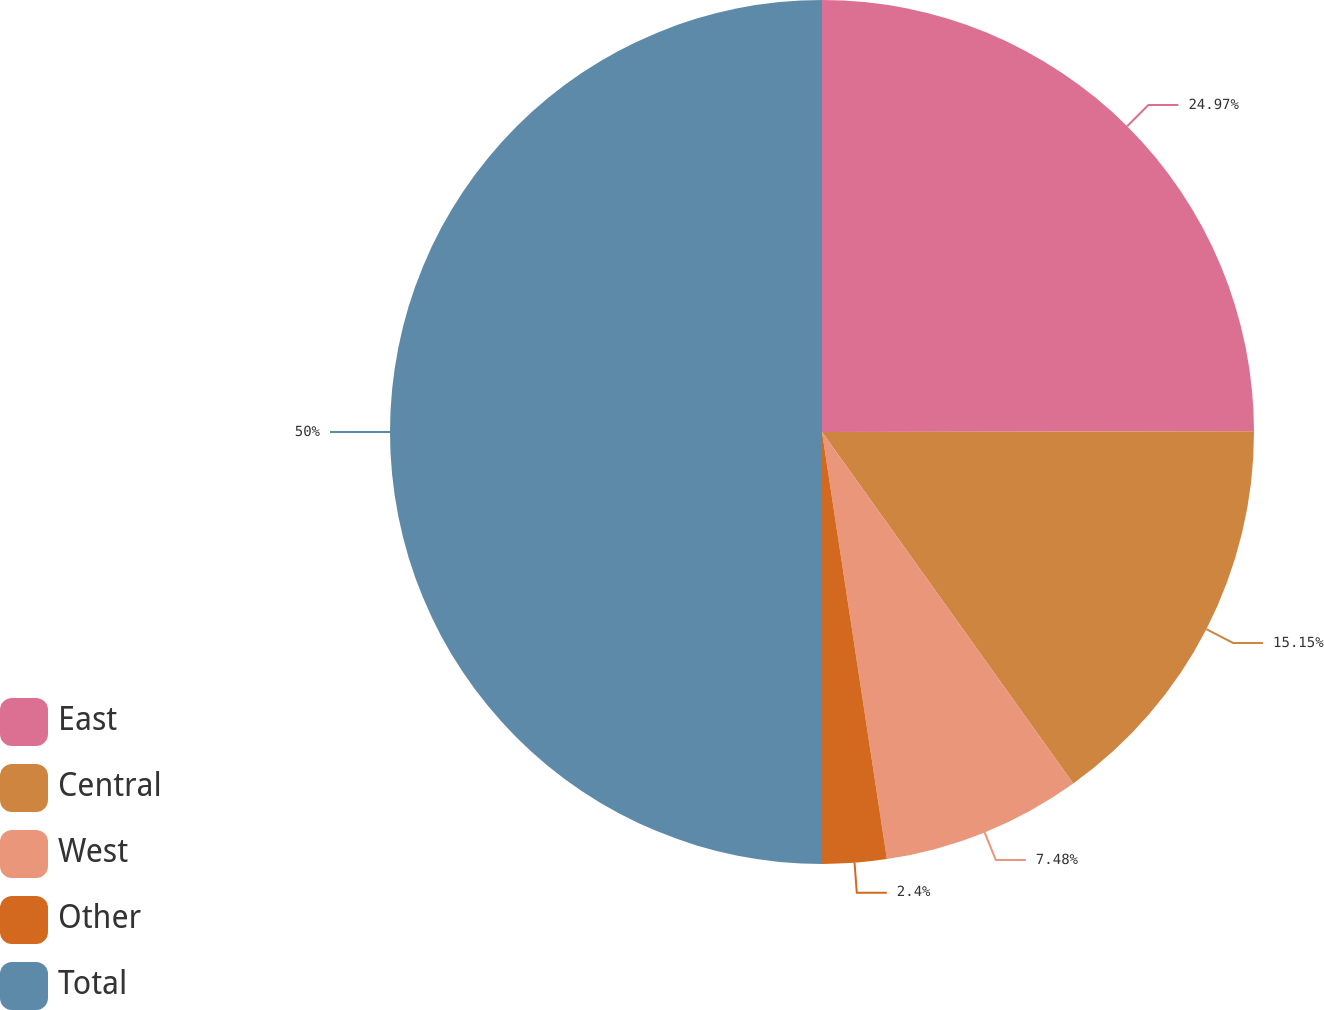<chart> <loc_0><loc_0><loc_500><loc_500><pie_chart><fcel>East<fcel>Central<fcel>West<fcel>Other<fcel>Total<nl><fcel>24.97%<fcel>15.15%<fcel>7.48%<fcel>2.4%<fcel>50.0%<nl></chart> 